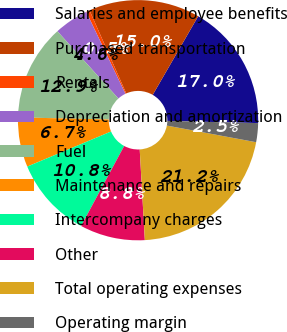Convert chart. <chart><loc_0><loc_0><loc_500><loc_500><pie_chart><fcel>Salaries and employee benefits<fcel>Purchased transportation<fcel>Rentals<fcel>Depreciation and amortization<fcel>Fuel<fcel>Maintenance and repairs<fcel>Intercompany charges<fcel>Other<fcel>Total operating expenses<fcel>Operating margin<nl><fcel>17.04%<fcel>14.97%<fcel>0.48%<fcel>4.62%<fcel>12.9%<fcel>6.69%<fcel>10.83%<fcel>8.76%<fcel>21.17%<fcel>2.55%<nl></chart> 